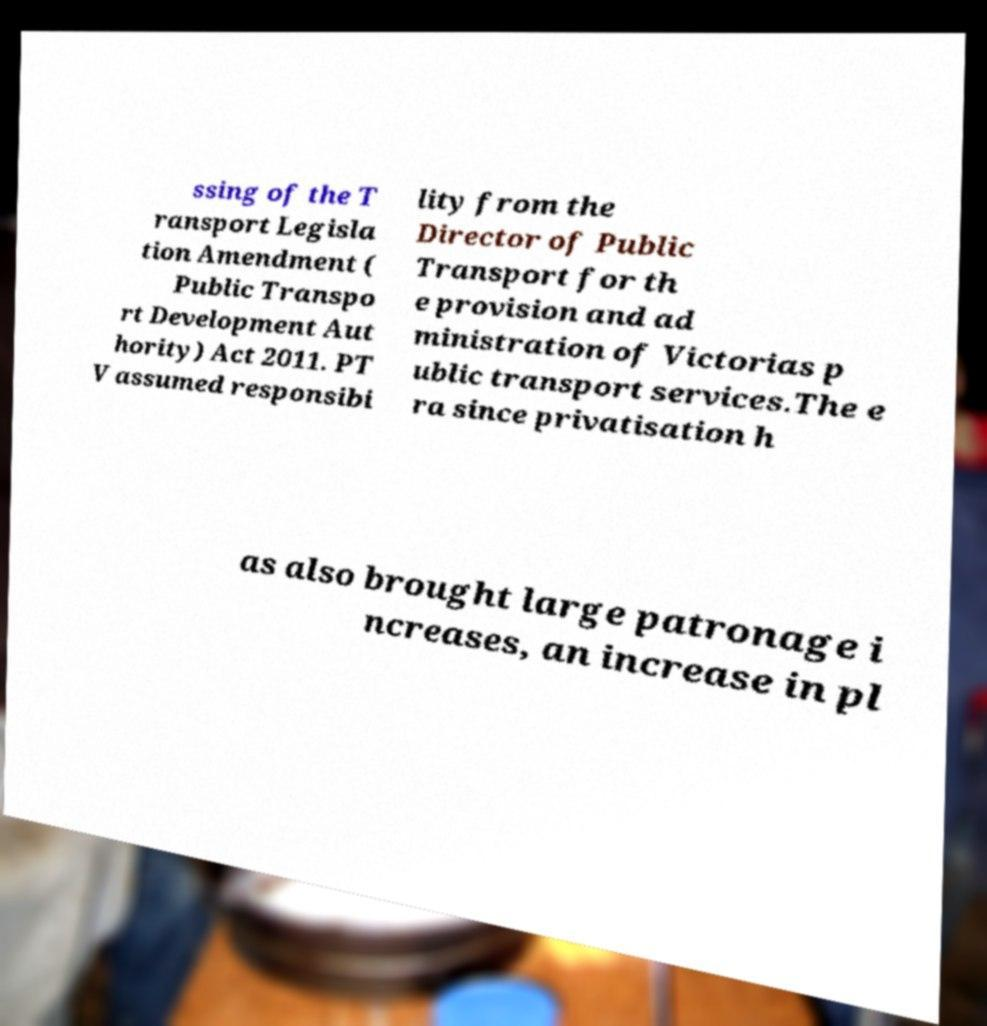Can you read and provide the text displayed in the image?This photo seems to have some interesting text. Can you extract and type it out for me? ssing of the T ransport Legisla tion Amendment ( Public Transpo rt Development Aut hority) Act 2011. PT V assumed responsibi lity from the Director of Public Transport for th e provision and ad ministration of Victorias p ublic transport services.The e ra since privatisation h as also brought large patronage i ncreases, an increase in pl 